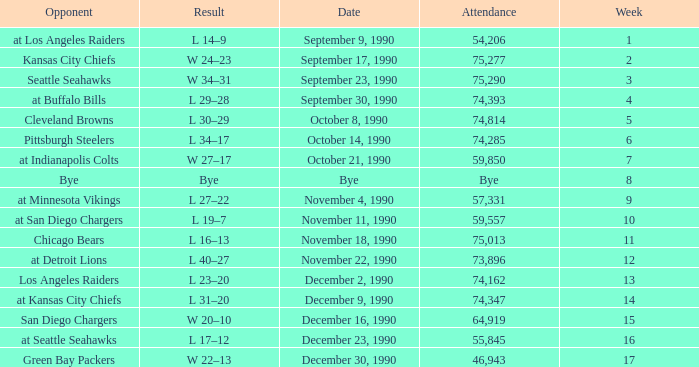What was the result for week 16? L 17–12. 